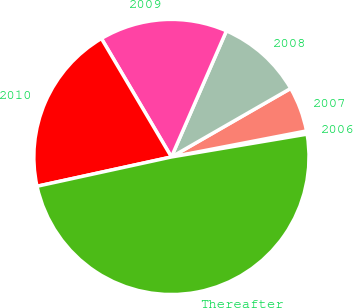<chart> <loc_0><loc_0><loc_500><loc_500><pie_chart><fcel>2006<fcel>2007<fcel>2008<fcel>2009<fcel>2010<fcel>Thereafter<nl><fcel>0.38%<fcel>5.27%<fcel>10.15%<fcel>15.04%<fcel>19.92%<fcel>49.23%<nl></chart> 